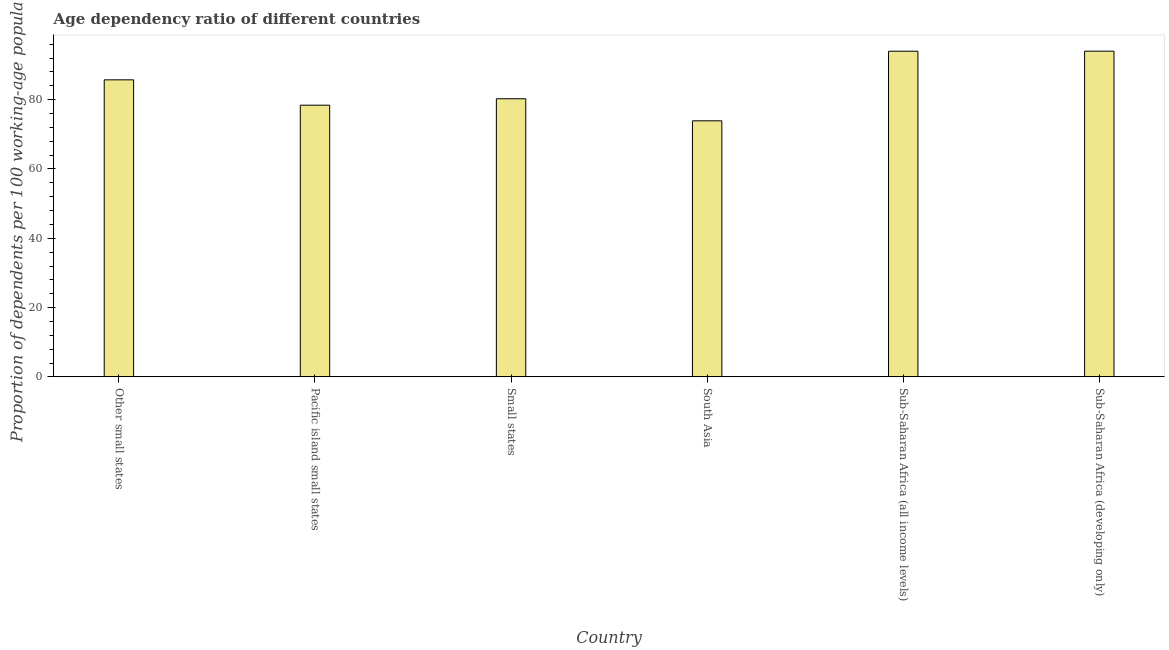Does the graph contain any zero values?
Your answer should be compact. No. What is the title of the graph?
Ensure brevity in your answer.  Age dependency ratio of different countries. What is the label or title of the Y-axis?
Give a very brief answer. Proportion of dependents per 100 working-age population. What is the age dependency ratio in South Asia?
Make the answer very short. 73.9. Across all countries, what is the maximum age dependency ratio?
Provide a short and direct response. 94.01. Across all countries, what is the minimum age dependency ratio?
Your answer should be very brief. 73.9. In which country was the age dependency ratio maximum?
Ensure brevity in your answer.  Sub-Saharan Africa (developing only). In which country was the age dependency ratio minimum?
Offer a very short reply. South Asia. What is the sum of the age dependency ratio?
Your answer should be very brief. 506.32. What is the difference between the age dependency ratio in Small states and Sub-Saharan Africa (developing only)?
Provide a short and direct response. -13.74. What is the average age dependency ratio per country?
Ensure brevity in your answer.  84.39. What is the median age dependency ratio?
Your response must be concise. 83. In how many countries, is the age dependency ratio greater than 76 ?
Your response must be concise. 5. What is the ratio of the age dependency ratio in Small states to that in Sub-Saharan Africa (developing only)?
Provide a succinct answer. 0.85. What is the difference between the highest and the second highest age dependency ratio?
Your answer should be very brief. 0.01. Is the sum of the age dependency ratio in South Asia and Sub-Saharan Africa (developing only) greater than the maximum age dependency ratio across all countries?
Offer a very short reply. Yes. What is the difference between the highest and the lowest age dependency ratio?
Offer a very short reply. 20.11. How many bars are there?
Your answer should be very brief. 6. Are the values on the major ticks of Y-axis written in scientific E-notation?
Offer a very short reply. No. What is the Proportion of dependents per 100 working-age population in Other small states?
Provide a succinct answer. 85.73. What is the Proportion of dependents per 100 working-age population in Pacific island small states?
Offer a terse response. 78.42. What is the Proportion of dependents per 100 working-age population of Small states?
Provide a succinct answer. 80.27. What is the Proportion of dependents per 100 working-age population of South Asia?
Your answer should be very brief. 73.9. What is the Proportion of dependents per 100 working-age population of Sub-Saharan Africa (all income levels)?
Offer a very short reply. 93.99. What is the Proportion of dependents per 100 working-age population of Sub-Saharan Africa (developing only)?
Your answer should be very brief. 94.01. What is the difference between the Proportion of dependents per 100 working-age population in Other small states and Pacific island small states?
Provide a short and direct response. 7.32. What is the difference between the Proportion of dependents per 100 working-age population in Other small states and Small states?
Provide a succinct answer. 5.46. What is the difference between the Proportion of dependents per 100 working-age population in Other small states and South Asia?
Make the answer very short. 11.83. What is the difference between the Proportion of dependents per 100 working-age population in Other small states and Sub-Saharan Africa (all income levels)?
Provide a succinct answer. -8.26. What is the difference between the Proportion of dependents per 100 working-age population in Other small states and Sub-Saharan Africa (developing only)?
Your answer should be compact. -8.28. What is the difference between the Proportion of dependents per 100 working-age population in Pacific island small states and Small states?
Your answer should be compact. -1.85. What is the difference between the Proportion of dependents per 100 working-age population in Pacific island small states and South Asia?
Your answer should be compact. 4.52. What is the difference between the Proportion of dependents per 100 working-age population in Pacific island small states and Sub-Saharan Africa (all income levels)?
Give a very brief answer. -15.58. What is the difference between the Proportion of dependents per 100 working-age population in Pacific island small states and Sub-Saharan Africa (developing only)?
Make the answer very short. -15.59. What is the difference between the Proportion of dependents per 100 working-age population in Small states and South Asia?
Provide a succinct answer. 6.37. What is the difference between the Proportion of dependents per 100 working-age population in Small states and Sub-Saharan Africa (all income levels)?
Offer a very short reply. -13.72. What is the difference between the Proportion of dependents per 100 working-age population in Small states and Sub-Saharan Africa (developing only)?
Give a very brief answer. -13.74. What is the difference between the Proportion of dependents per 100 working-age population in South Asia and Sub-Saharan Africa (all income levels)?
Offer a very short reply. -20.09. What is the difference between the Proportion of dependents per 100 working-age population in South Asia and Sub-Saharan Africa (developing only)?
Your answer should be compact. -20.11. What is the difference between the Proportion of dependents per 100 working-age population in Sub-Saharan Africa (all income levels) and Sub-Saharan Africa (developing only)?
Your answer should be compact. -0.01. What is the ratio of the Proportion of dependents per 100 working-age population in Other small states to that in Pacific island small states?
Offer a terse response. 1.09. What is the ratio of the Proportion of dependents per 100 working-age population in Other small states to that in Small states?
Ensure brevity in your answer.  1.07. What is the ratio of the Proportion of dependents per 100 working-age population in Other small states to that in South Asia?
Keep it short and to the point. 1.16. What is the ratio of the Proportion of dependents per 100 working-age population in Other small states to that in Sub-Saharan Africa (all income levels)?
Your answer should be very brief. 0.91. What is the ratio of the Proportion of dependents per 100 working-age population in Other small states to that in Sub-Saharan Africa (developing only)?
Your answer should be very brief. 0.91. What is the ratio of the Proportion of dependents per 100 working-age population in Pacific island small states to that in Small states?
Provide a succinct answer. 0.98. What is the ratio of the Proportion of dependents per 100 working-age population in Pacific island small states to that in South Asia?
Give a very brief answer. 1.06. What is the ratio of the Proportion of dependents per 100 working-age population in Pacific island small states to that in Sub-Saharan Africa (all income levels)?
Provide a short and direct response. 0.83. What is the ratio of the Proportion of dependents per 100 working-age population in Pacific island small states to that in Sub-Saharan Africa (developing only)?
Offer a terse response. 0.83. What is the ratio of the Proportion of dependents per 100 working-age population in Small states to that in South Asia?
Your answer should be compact. 1.09. What is the ratio of the Proportion of dependents per 100 working-age population in Small states to that in Sub-Saharan Africa (all income levels)?
Provide a short and direct response. 0.85. What is the ratio of the Proportion of dependents per 100 working-age population in Small states to that in Sub-Saharan Africa (developing only)?
Your answer should be very brief. 0.85. What is the ratio of the Proportion of dependents per 100 working-age population in South Asia to that in Sub-Saharan Africa (all income levels)?
Your answer should be very brief. 0.79. What is the ratio of the Proportion of dependents per 100 working-age population in South Asia to that in Sub-Saharan Africa (developing only)?
Give a very brief answer. 0.79. 